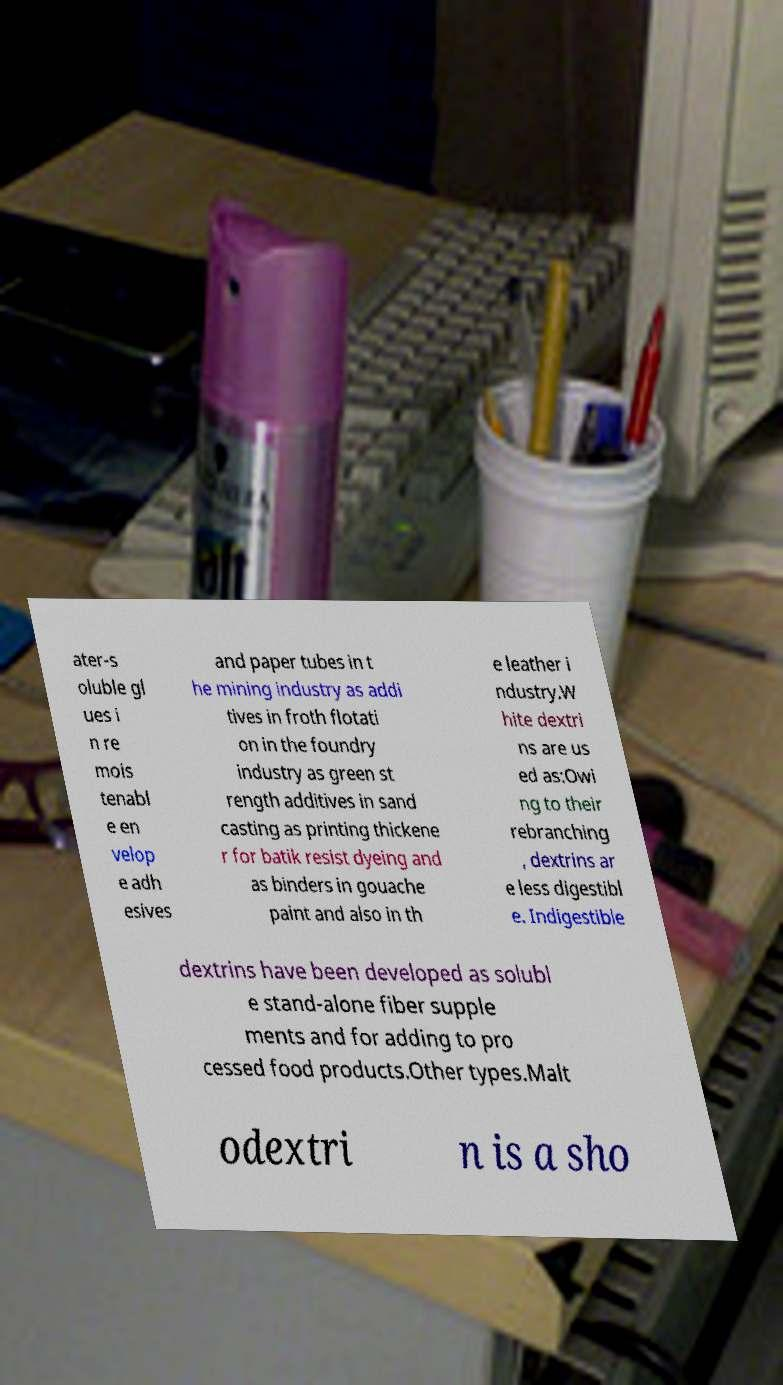I need the written content from this picture converted into text. Can you do that? ater-s oluble gl ues i n re mois tenabl e en velop e adh esives and paper tubes in t he mining industry as addi tives in froth flotati on in the foundry industry as green st rength additives in sand casting as printing thickene r for batik resist dyeing and as binders in gouache paint and also in th e leather i ndustry.W hite dextri ns are us ed as:Owi ng to their rebranching , dextrins ar e less digestibl e. Indigestible dextrins have been developed as solubl e stand-alone fiber supple ments and for adding to pro cessed food products.Other types.Malt odextri n is a sho 